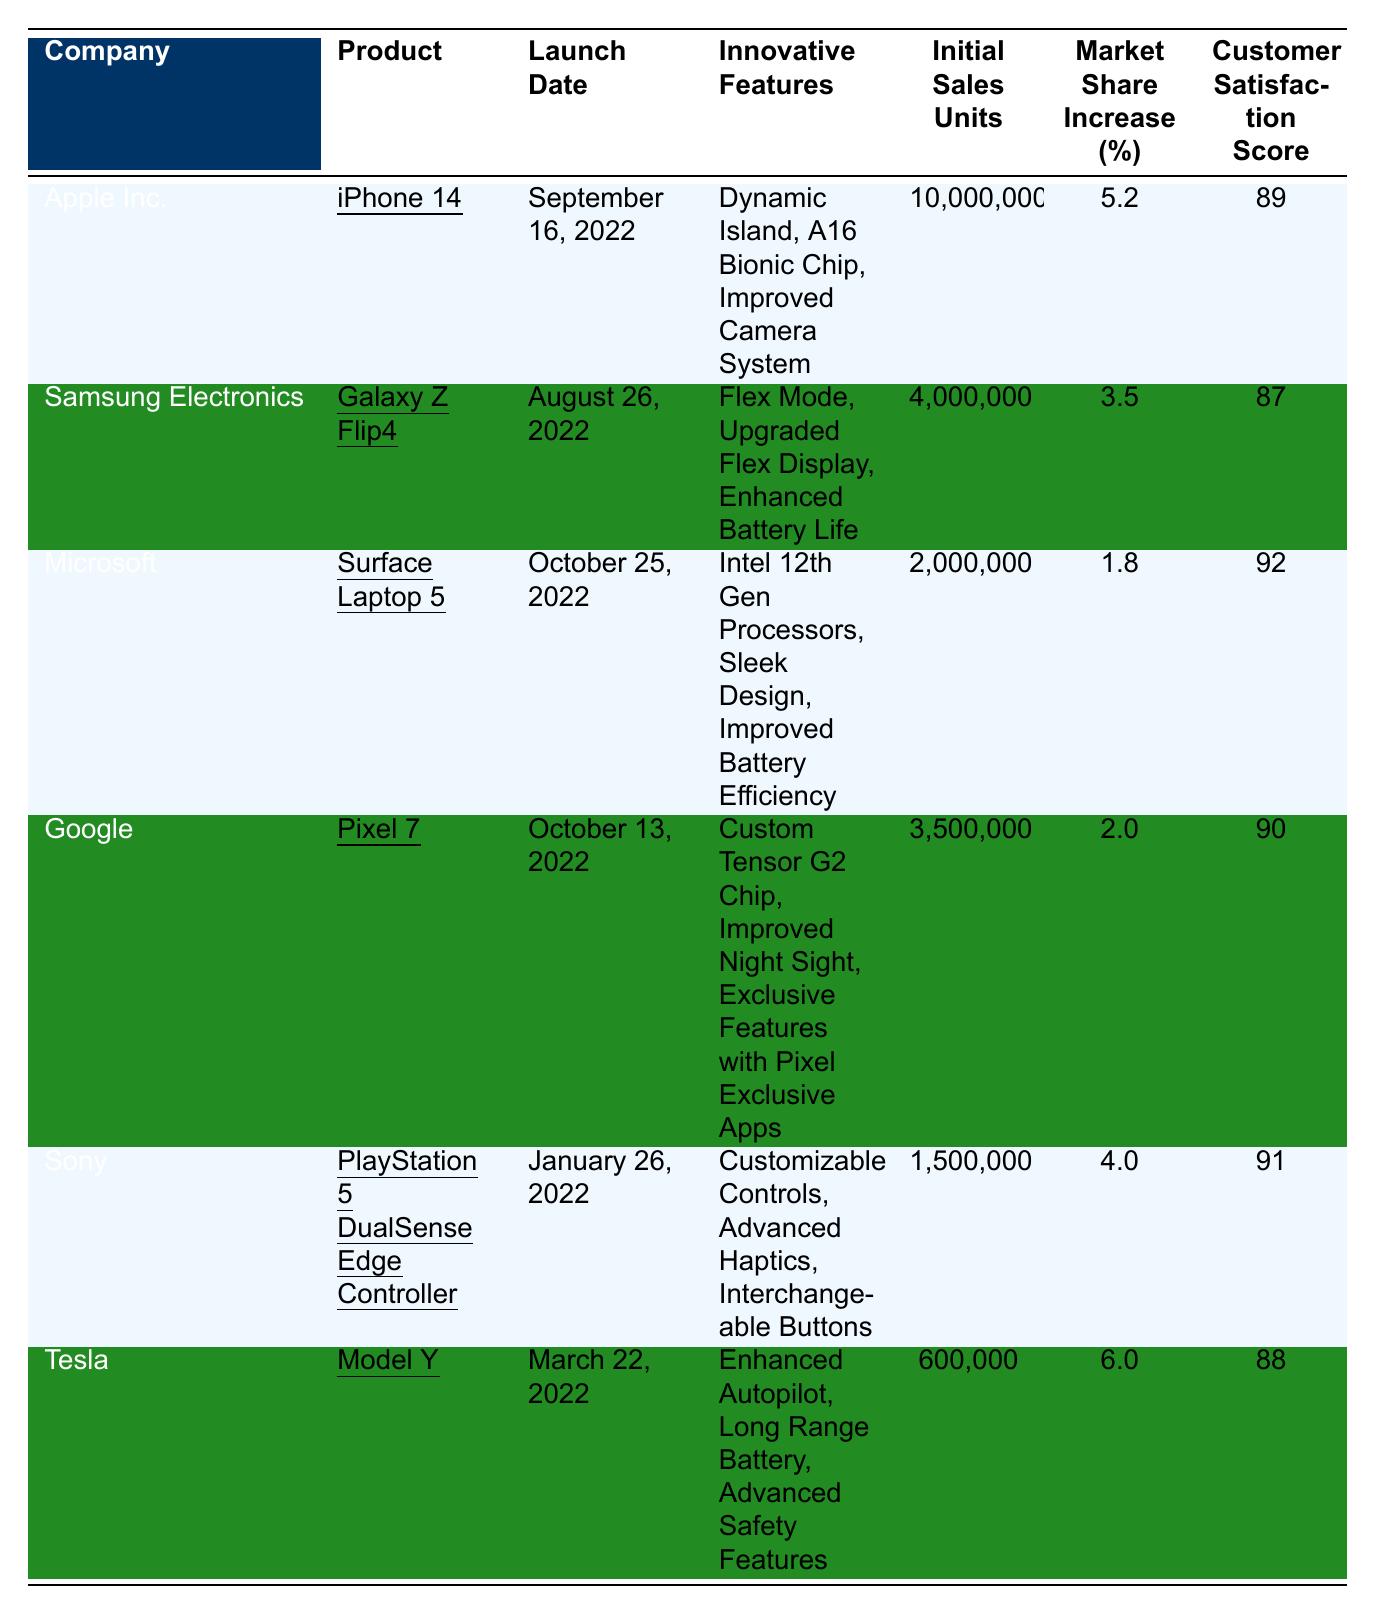What is the initial sales unit of iPhone 14? According to the table, the initial sales units for the iPhone 14 are explicitly stated as 10,000,000.
Answer: 10,000,000 Which product had the highest customer satisfaction score? The table lists customer satisfaction scores for various products, and the highest score is 92 for the Surface Laptop 5.
Answer: Surface Laptop 5 What is the market share increase for Tesla's Model Y? The table indicates that the market share increase for Tesla's Model Y is 6.0%.
Answer: 6.0% Calculate the average customer satisfaction score for the products listed. To find the average, sum the customer satisfaction scores: 89 + 87 + 92 + 90 + 91 + 88 = 517. There are 6 products, so the average is 517 / 6 = 86.17.
Answer: 86.17 Is the innovative feature "Dynamic Island" unique to any product? The table shows that "Dynamic Island" is listed as an innovative feature only for the iPhone 14, indicating it is unique to that product.
Answer: Yes Which company had the lowest initial sales units? The table shows the initial sales units for all products, and the lowest is 600,000 for Tesla's Model Y, compared to other products.
Answer: Tesla What is the difference between the customer satisfaction scores of the iPhone 14 and the Galaxy Z Flip4? The score for iPhone 14 is 89, and for Galaxy Z Flip4 it is 87. The difference is calculated as 89 - 87 = 2.
Answer: 2 List the innovative features of Google Pixel 7. The table specifies the innovative features for Google Pixel 7 as: Custom Tensor G2 Chip, Improved Night Sight, Exclusive Features with Pixel Exclusive Apps.
Answer: Custom Tensor G2 Chip, Improved Night Sight, Exclusive Features with Pixel Exclusive Apps Do all products have a customer satisfaction score of 85 or higher? By checking the table, the scores for all products are above 85, confirming that all product scores are satisfactory.
Answer: Yes What product had a market share increase of less than 3%? The table indicates that the Surface Laptop 5 and Google Pixel 7 both have market share increases below 3%, specifically 1.8% and 2.0% respectively.
Answer: Surface Laptop 5, Google Pixel 7 What is the total initial sales units for Samsung and Sony's products combined? To find the total, add Samsung's initial sales units (4,000,000) to Sony's (1,500,000) which gives 4,000,000 + 1,500,000 = 5,500,000.
Answer: 5,500,000 